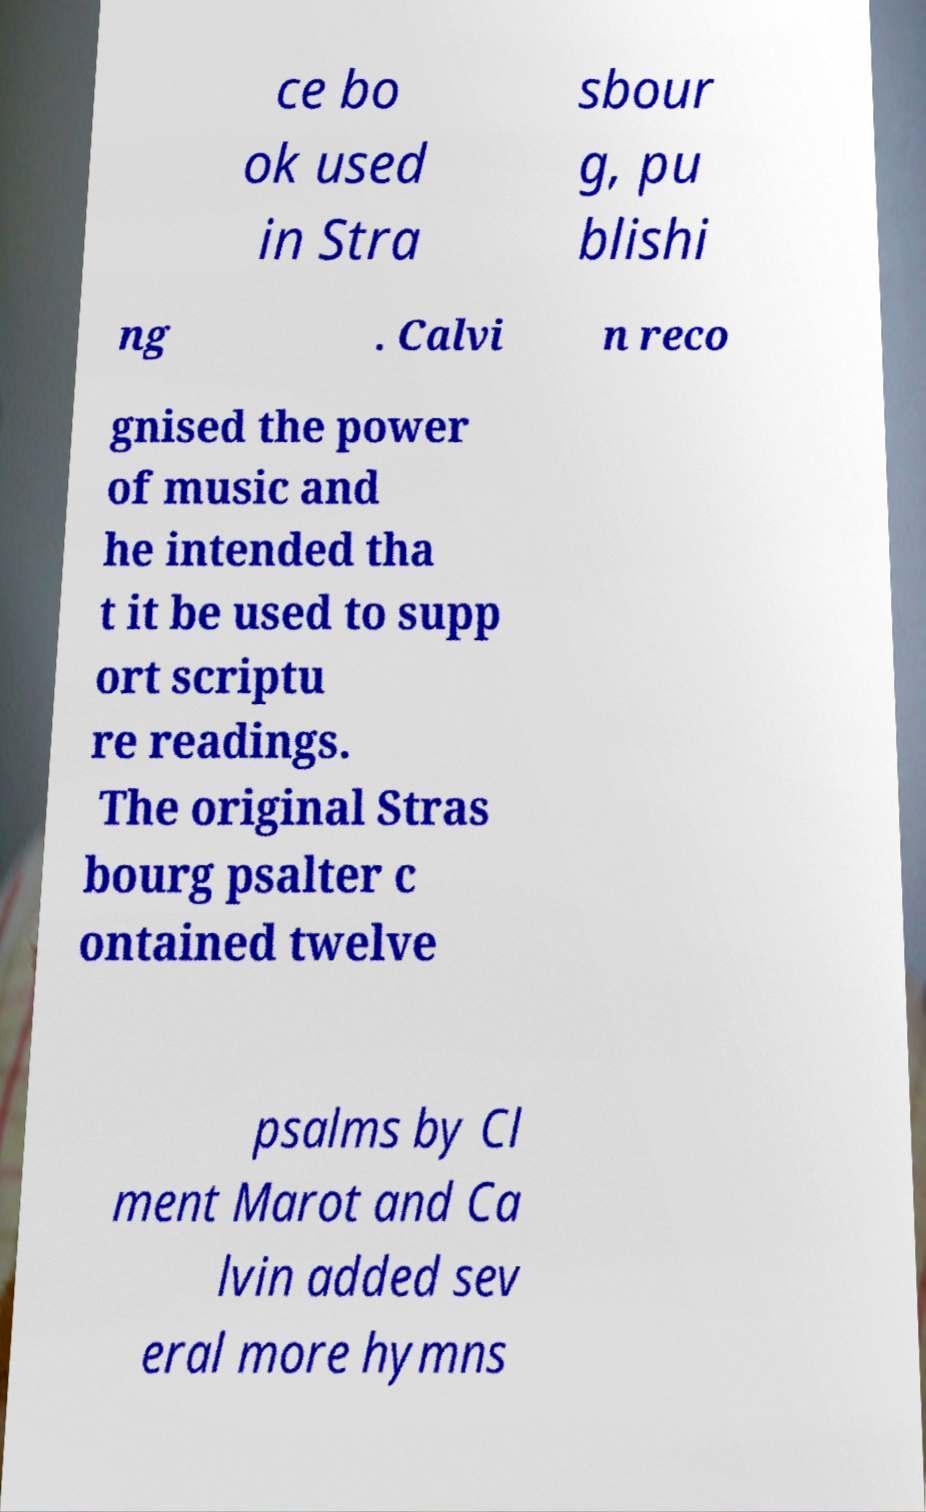Please identify and transcribe the text found in this image. ce bo ok used in Stra sbour g, pu blishi ng . Calvi n reco gnised the power of music and he intended tha t it be used to supp ort scriptu re readings. The original Stras bourg psalter c ontained twelve psalms by Cl ment Marot and Ca lvin added sev eral more hymns 